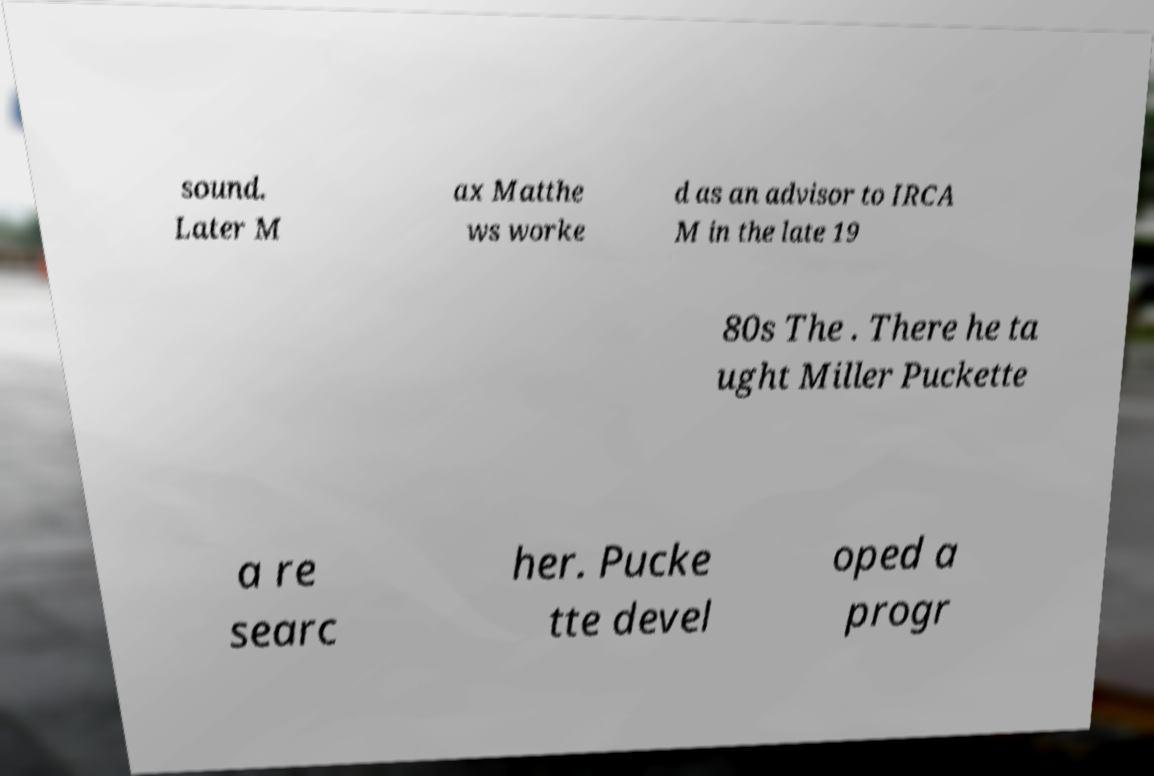I need the written content from this picture converted into text. Can you do that? sound. Later M ax Matthe ws worke d as an advisor to IRCA M in the late 19 80s The . There he ta ught Miller Puckette a re searc her. Pucke tte devel oped a progr 